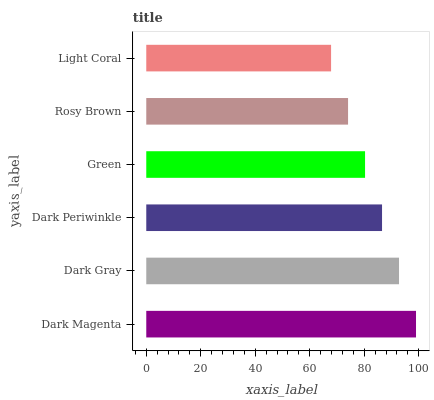Is Light Coral the minimum?
Answer yes or no. Yes. Is Dark Magenta the maximum?
Answer yes or no. Yes. Is Dark Gray the minimum?
Answer yes or no. No. Is Dark Gray the maximum?
Answer yes or no. No. Is Dark Magenta greater than Dark Gray?
Answer yes or no. Yes. Is Dark Gray less than Dark Magenta?
Answer yes or no. Yes. Is Dark Gray greater than Dark Magenta?
Answer yes or no. No. Is Dark Magenta less than Dark Gray?
Answer yes or no. No. Is Dark Periwinkle the high median?
Answer yes or no. Yes. Is Green the low median?
Answer yes or no. Yes. Is Dark Magenta the high median?
Answer yes or no. No. Is Dark Periwinkle the low median?
Answer yes or no. No. 